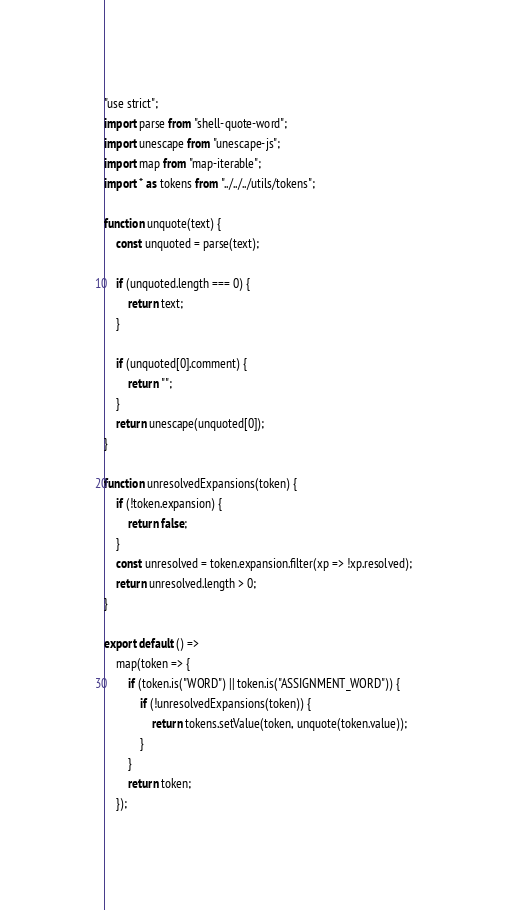<code> <loc_0><loc_0><loc_500><loc_500><_TypeScript_>"use strict";
import parse from "shell-quote-word";
import unescape from "unescape-js";
import map from "map-iterable";
import * as tokens from "../../../utils/tokens";

function unquote(text) {
	const unquoted = parse(text);

	if (unquoted.length === 0) {
		return text;
	}

	if (unquoted[0].comment) {
		return "";
	}
	return unescape(unquoted[0]);
}

function unresolvedExpansions(token) {
	if (!token.expansion) {
		return false;
	}
	const unresolved = token.expansion.filter(xp => !xp.resolved);
	return unresolved.length > 0;
}

export default () =>
	map(token => {
		if (token.is("WORD") || token.is("ASSIGNMENT_WORD")) {
			if (!unresolvedExpansions(token)) {
				return tokens.setValue(token, unquote(token.value));
			}
		}
		return token;
	});
</code> 